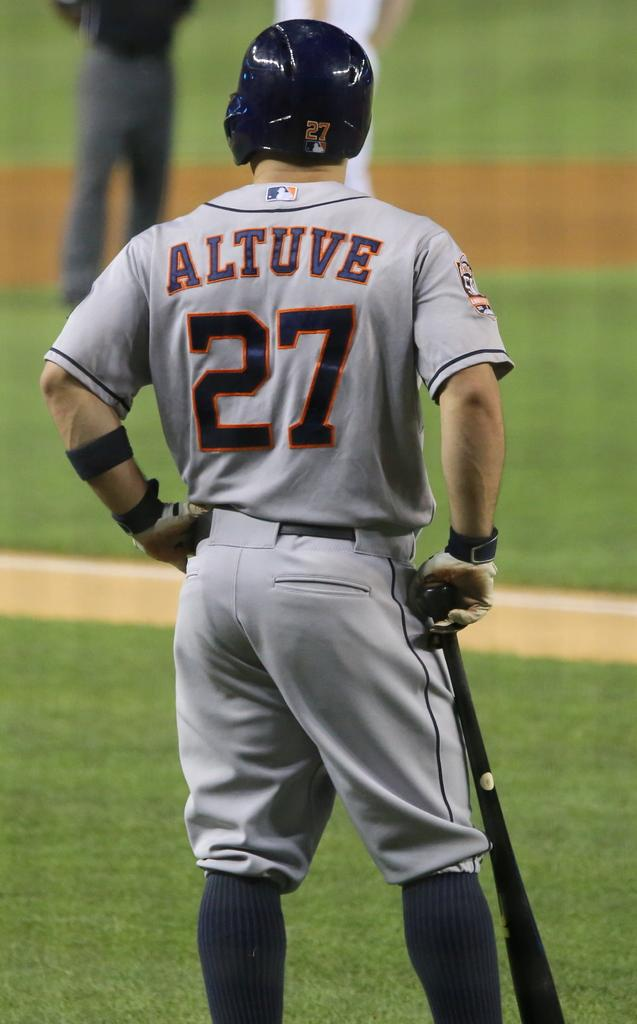<image>
Write a terse but informative summary of the picture. a baseball player in a grey 27 Altuve jersey waiting to bat 